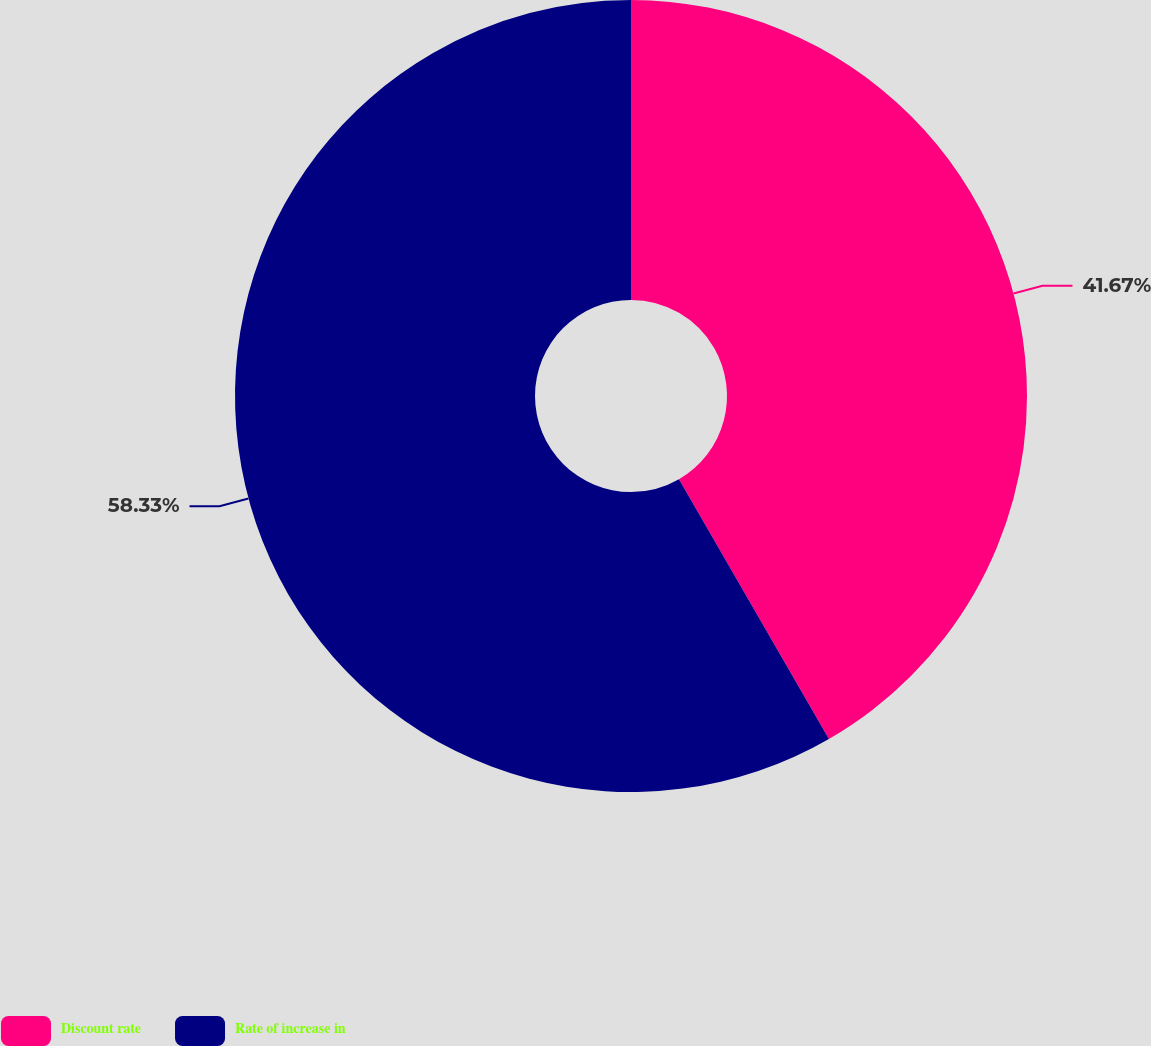Convert chart to OTSL. <chart><loc_0><loc_0><loc_500><loc_500><pie_chart><fcel>Discount rate<fcel>Rate of increase in<nl><fcel>41.67%<fcel>58.33%<nl></chart> 